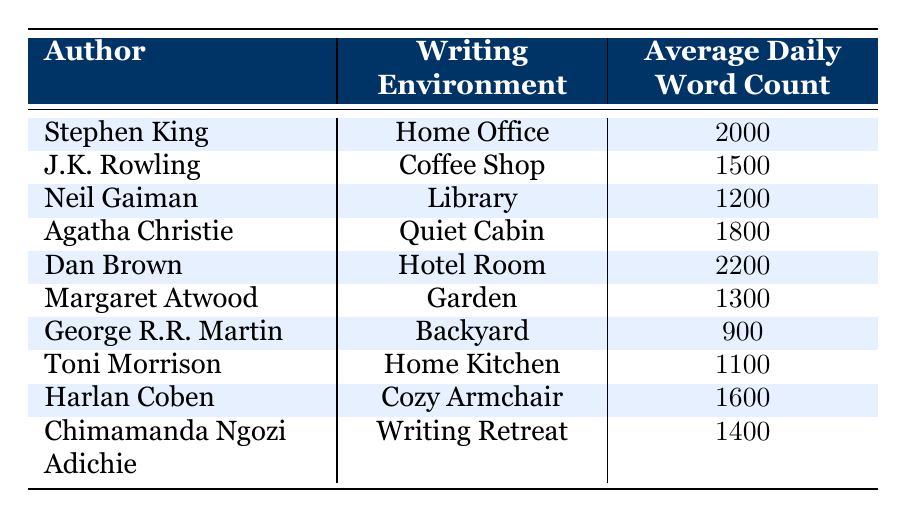What is the average daily word count for Stephen King? The table lists Stephen King's average daily word count under the "Average Daily Word Count" column, which shows 2000 words.
Answer: 2000 How many authors write in a Cozy Armchair? The table has only one entry for the Cozy Armchair environment, which is Harlan Coben, making the count equal to one.
Answer: 1 Which author has the highest average daily word count? Scanning through the "Average Daily Word Count" column, I find that Dan Brown has the highest count at 2200 words, which is greater than all other entries.
Answer: Dan Brown What is the total average daily word count of authors who write in a Quiet Cabin and Hotel Room? In the table, Agatha Christie, in the Quiet Cabin, has 1800 words and Dan Brown, in the Hotel Room, has 2200 words. Adding these gives 1800 + 2200 = 4000.
Answer: 4000 Is it true that all authors listed have an average daily word count of more than 800 words? Checking the lowest entry in the "Average Daily Word Count" column, George R.R. Martin has 900 words, which confirms that all authors' counts exceed 800 words.
Answer: Yes What is the difference in average daily word count between writers in a Library and a Coffee Shop? Neil Gaiman has 1200 words in the Library, while J.K. Rowling has 1500 words in the Coffee Shop. The difference is calculated as 1500 - 1200 = 300 words.
Answer: 300 Which two authors write in environments that are the most conducive to getting higher word counts? Comparing environments, Dan Brown in a Hotel Room at 2200 words and Stephen King in a Home Office at 2000 words have the highest word counts. Therefore, they represent the most conducive environments.
Answer: Dan Brown, Stephen King How many environments listed have average daily word counts of less than 1300 words? The relevant authors from the table are George R.R. Martin with 900 words and Toni Morrison with 1100 words. This totals two authors, so there are two environments with counts less than 1300.
Answer: 2 